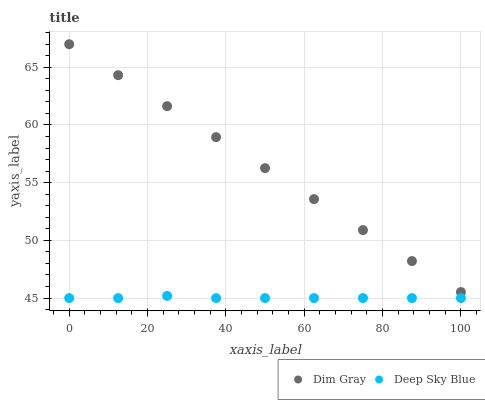Does Deep Sky Blue have the minimum area under the curve?
Answer yes or no. Yes. Does Dim Gray have the maximum area under the curve?
Answer yes or no. Yes. Does Deep Sky Blue have the maximum area under the curve?
Answer yes or no. No. Is Dim Gray the smoothest?
Answer yes or no. Yes. Is Deep Sky Blue the roughest?
Answer yes or no. Yes. Is Deep Sky Blue the smoothest?
Answer yes or no. No. Does Deep Sky Blue have the lowest value?
Answer yes or no. Yes. Does Dim Gray have the highest value?
Answer yes or no. Yes. Does Deep Sky Blue have the highest value?
Answer yes or no. No. Is Deep Sky Blue less than Dim Gray?
Answer yes or no. Yes. Is Dim Gray greater than Deep Sky Blue?
Answer yes or no. Yes. Does Deep Sky Blue intersect Dim Gray?
Answer yes or no. No. 